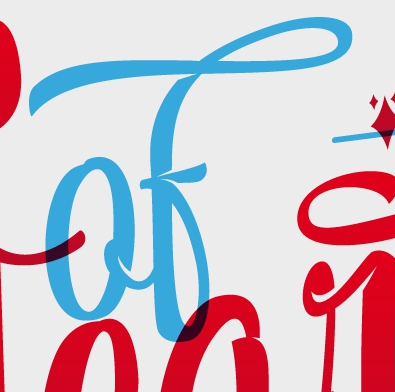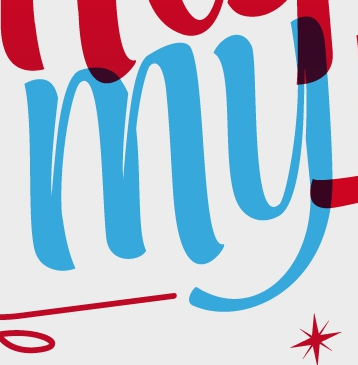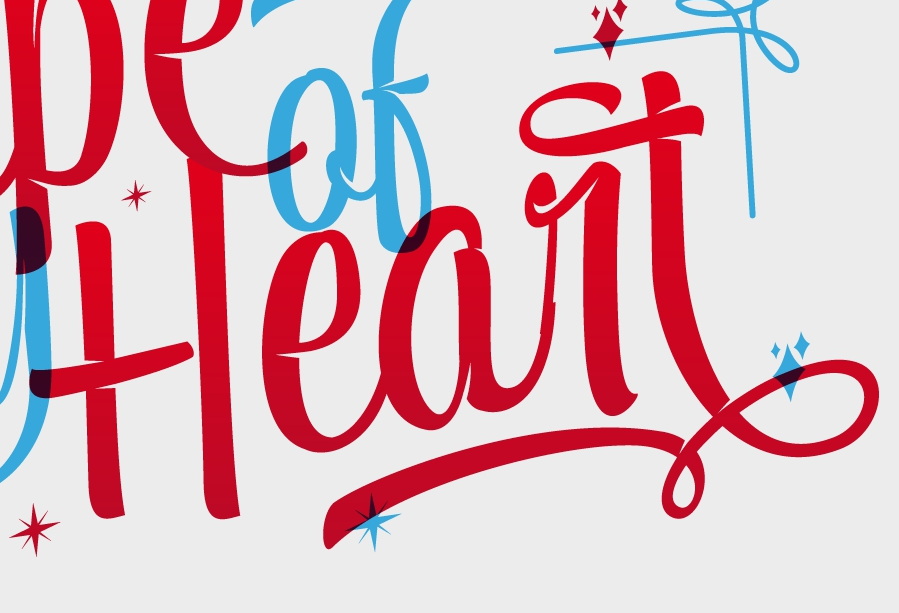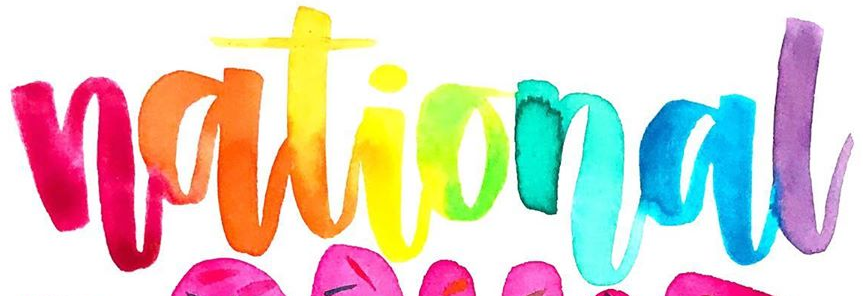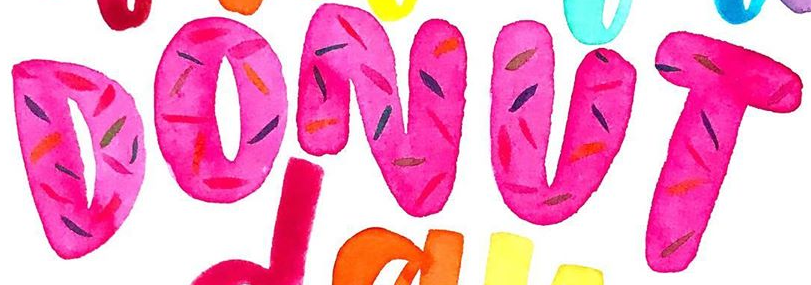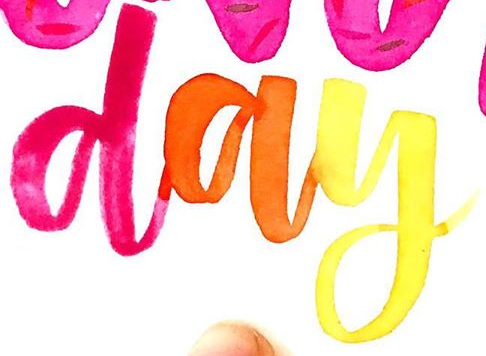Transcribe the words shown in these images in order, separated by a semicolon. of; my; Heart; national; DONUT; day 